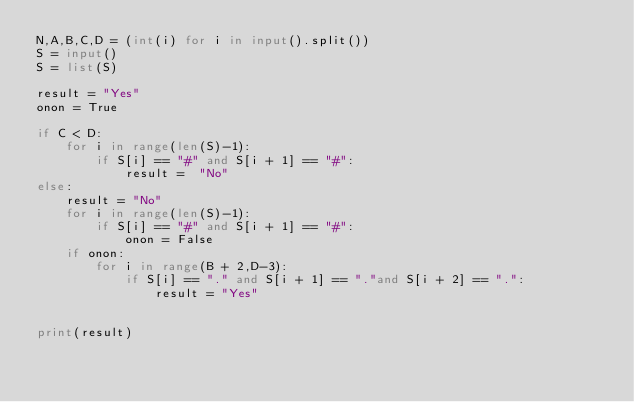Convert code to text. <code><loc_0><loc_0><loc_500><loc_500><_Python_>N,A,B,C,D = (int(i) for i in input().split())
S = input()
S = list(S)

result = "Yes"
onon = True

if C < D:
    for i in range(len(S)-1):
        if S[i] == "#" and S[i + 1] == "#":
            result =  "No"
else:
    result = "No"
    for i in range(len(S)-1):
        if S[i] == "#" and S[i + 1] == "#":
            onon = False
    if onon:
        for i in range(B + 2,D-3):
            if S[i] == "." and S[i + 1] == "."and S[i + 2] == ".":
                result = "Yes"


print(result)</code> 